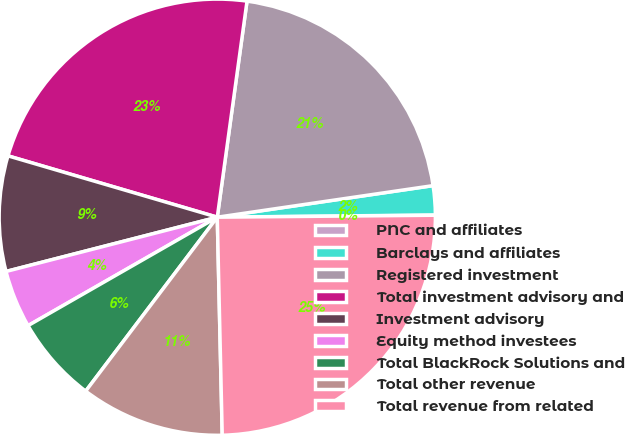<chart> <loc_0><loc_0><loc_500><loc_500><pie_chart><fcel>PNC and affiliates<fcel>Barclays and affiliates<fcel>Registered investment<fcel>Total investment advisory and<fcel>Investment advisory<fcel>Equity method investees<fcel>Total BlackRock Solutions and<fcel>Total other revenue<fcel>Total revenue from related<nl><fcel>0.02%<fcel>2.15%<fcel>20.51%<fcel>22.64%<fcel>8.54%<fcel>4.28%<fcel>6.41%<fcel>10.67%<fcel>24.78%<nl></chart> 